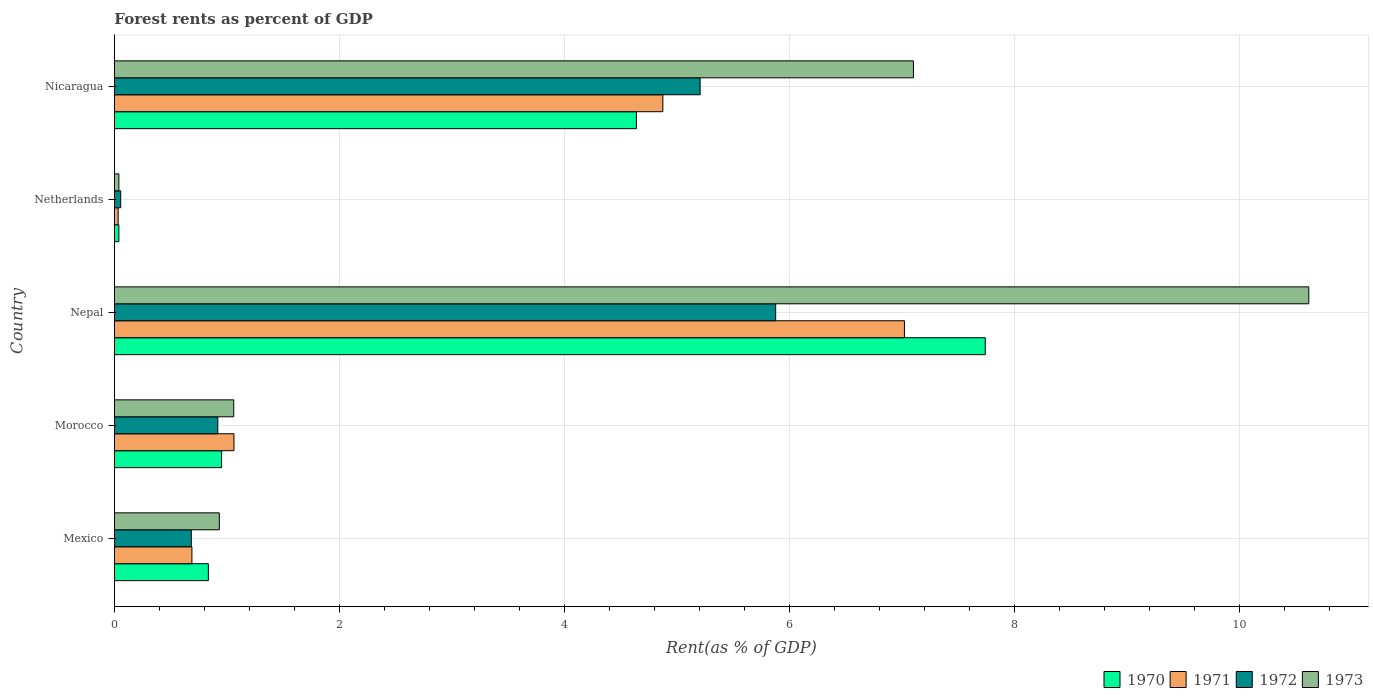How many different coloured bars are there?
Give a very brief answer. 4. Are the number of bars on each tick of the Y-axis equal?
Make the answer very short. Yes. How many bars are there on the 3rd tick from the bottom?
Give a very brief answer. 4. What is the label of the 2nd group of bars from the top?
Ensure brevity in your answer.  Netherlands. What is the forest rent in 1973 in Netherlands?
Ensure brevity in your answer.  0.04. Across all countries, what is the maximum forest rent in 1970?
Offer a very short reply. 7.74. Across all countries, what is the minimum forest rent in 1973?
Your answer should be compact. 0.04. In which country was the forest rent in 1972 maximum?
Make the answer very short. Nepal. In which country was the forest rent in 1970 minimum?
Your response must be concise. Netherlands. What is the total forest rent in 1973 in the graph?
Offer a terse response. 19.75. What is the difference between the forest rent in 1973 in Morocco and that in Netherlands?
Your response must be concise. 1.02. What is the difference between the forest rent in 1973 in Morocco and the forest rent in 1972 in Nicaragua?
Make the answer very short. -4.14. What is the average forest rent in 1970 per country?
Offer a very short reply. 2.84. What is the difference between the forest rent in 1970 and forest rent in 1972 in Mexico?
Provide a succinct answer. 0.15. What is the ratio of the forest rent in 1972 in Mexico to that in Nepal?
Keep it short and to the point. 0.12. Is the forest rent in 1972 in Morocco less than that in Netherlands?
Your response must be concise. No. Is the difference between the forest rent in 1970 in Morocco and Netherlands greater than the difference between the forest rent in 1972 in Morocco and Netherlands?
Offer a very short reply. Yes. What is the difference between the highest and the second highest forest rent in 1972?
Offer a very short reply. 0.67. What is the difference between the highest and the lowest forest rent in 1971?
Your answer should be very brief. 6.99. What does the 4th bar from the top in Mexico represents?
Offer a terse response. 1970. Is it the case that in every country, the sum of the forest rent in 1973 and forest rent in 1972 is greater than the forest rent in 1971?
Offer a very short reply. Yes. How many bars are there?
Offer a very short reply. 20. Are all the bars in the graph horizontal?
Ensure brevity in your answer.  Yes. How many countries are there in the graph?
Provide a succinct answer. 5. Are the values on the major ticks of X-axis written in scientific E-notation?
Your answer should be very brief. No. Does the graph contain any zero values?
Offer a terse response. No. How many legend labels are there?
Give a very brief answer. 4. What is the title of the graph?
Your answer should be very brief. Forest rents as percent of GDP. Does "1960" appear as one of the legend labels in the graph?
Make the answer very short. No. What is the label or title of the X-axis?
Offer a very short reply. Rent(as % of GDP). What is the Rent(as % of GDP) of 1970 in Mexico?
Give a very brief answer. 0.83. What is the Rent(as % of GDP) in 1971 in Mexico?
Make the answer very short. 0.69. What is the Rent(as % of GDP) in 1972 in Mexico?
Provide a short and direct response. 0.68. What is the Rent(as % of GDP) of 1973 in Mexico?
Keep it short and to the point. 0.93. What is the Rent(as % of GDP) of 1970 in Morocco?
Make the answer very short. 0.95. What is the Rent(as % of GDP) in 1971 in Morocco?
Your response must be concise. 1.06. What is the Rent(as % of GDP) in 1972 in Morocco?
Provide a short and direct response. 0.92. What is the Rent(as % of GDP) in 1973 in Morocco?
Keep it short and to the point. 1.06. What is the Rent(as % of GDP) in 1970 in Nepal?
Provide a short and direct response. 7.74. What is the Rent(as % of GDP) in 1971 in Nepal?
Ensure brevity in your answer.  7.02. What is the Rent(as % of GDP) in 1972 in Nepal?
Keep it short and to the point. 5.88. What is the Rent(as % of GDP) in 1973 in Nepal?
Your answer should be compact. 10.61. What is the Rent(as % of GDP) of 1970 in Netherlands?
Your answer should be very brief. 0.04. What is the Rent(as % of GDP) in 1971 in Netherlands?
Provide a succinct answer. 0.03. What is the Rent(as % of GDP) of 1972 in Netherlands?
Offer a terse response. 0.06. What is the Rent(as % of GDP) in 1973 in Netherlands?
Ensure brevity in your answer.  0.04. What is the Rent(as % of GDP) of 1970 in Nicaragua?
Provide a succinct answer. 4.64. What is the Rent(as % of GDP) of 1971 in Nicaragua?
Make the answer very short. 4.87. What is the Rent(as % of GDP) of 1972 in Nicaragua?
Your answer should be very brief. 5.21. What is the Rent(as % of GDP) of 1973 in Nicaragua?
Give a very brief answer. 7.1. Across all countries, what is the maximum Rent(as % of GDP) of 1970?
Your response must be concise. 7.74. Across all countries, what is the maximum Rent(as % of GDP) of 1971?
Keep it short and to the point. 7.02. Across all countries, what is the maximum Rent(as % of GDP) of 1972?
Keep it short and to the point. 5.88. Across all countries, what is the maximum Rent(as % of GDP) in 1973?
Keep it short and to the point. 10.61. Across all countries, what is the minimum Rent(as % of GDP) of 1970?
Provide a succinct answer. 0.04. Across all countries, what is the minimum Rent(as % of GDP) of 1971?
Keep it short and to the point. 0.03. Across all countries, what is the minimum Rent(as % of GDP) of 1972?
Offer a very short reply. 0.06. Across all countries, what is the minimum Rent(as % of GDP) in 1973?
Your response must be concise. 0.04. What is the total Rent(as % of GDP) of 1970 in the graph?
Ensure brevity in your answer.  14.2. What is the total Rent(as % of GDP) in 1971 in the graph?
Ensure brevity in your answer.  13.68. What is the total Rent(as % of GDP) in 1972 in the graph?
Offer a very short reply. 12.74. What is the total Rent(as % of GDP) of 1973 in the graph?
Keep it short and to the point. 19.75. What is the difference between the Rent(as % of GDP) of 1970 in Mexico and that in Morocco?
Ensure brevity in your answer.  -0.12. What is the difference between the Rent(as % of GDP) in 1971 in Mexico and that in Morocco?
Provide a succinct answer. -0.37. What is the difference between the Rent(as % of GDP) in 1972 in Mexico and that in Morocco?
Keep it short and to the point. -0.24. What is the difference between the Rent(as % of GDP) of 1973 in Mexico and that in Morocco?
Your answer should be very brief. -0.13. What is the difference between the Rent(as % of GDP) in 1970 in Mexico and that in Nepal?
Give a very brief answer. -6.9. What is the difference between the Rent(as % of GDP) of 1971 in Mexico and that in Nepal?
Your answer should be compact. -6.33. What is the difference between the Rent(as % of GDP) of 1972 in Mexico and that in Nepal?
Keep it short and to the point. -5.19. What is the difference between the Rent(as % of GDP) in 1973 in Mexico and that in Nepal?
Provide a succinct answer. -9.68. What is the difference between the Rent(as % of GDP) of 1970 in Mexico and that in Netherlands?
Your answer should be very brief. 0.8. What is the difference between the Rent(as % of GDP) of 1971 in Mexico and that in Netherlands?
Your answer should be compact. 0.66. What is the difference between the Rent(as % of GDP) in 1972 in Mexico and that in Netherlands?
Make the answer very short. 0.63. What is the difference between the Rent(as % of GDP) in 1973 in Mexico and that in Netherlands?
Give a very brief answer. 0.89. What is the difference between the Rent(as % of GDP) of 1970 in Mexico and that in Nicaragua?
Provide a succinct answer. -3.8. What is the difference between the Rent(as % of GDP) in 1971 in Mexico and that in Nicaragua?
Keep it short and to the point. -4.19. What is the difference between the Rent(as % of GDP) in 1972 in Mexico and that in Nicaragua?
Offer a very short reply. -4.52. What is the difference between the Rent(as % of GDP) of 1973 in Mexico and that in Nicaragua?
Keep it short and to the point. -6.17. What is the difference between the Rent(as % of GDP) of 1970 in Morocco and that in Nepal?
Keep it short and to the point. -6.79. What is the difference between the Rent(as % of GDP) of 1971 in Morocco and that in Nepal?
Provide a short and direct response. -5.96. What is the difference between the Rent(as % of GDP) of 1972 in Morocco and that in Nepal?
Provide a succinct answer. -4.96. What is the difference between the Rent(as % of GDP) of 1973 in Morocco and that in Nepal?
Your answer should be compact. -9.55. What is the difference between the Rent(as % of GDP) in 1970 in Morocco and that in Netherlands?
Your answer should be very brief. 0.91. What is the difference between the Rent(as % of GDP) of 1971 in Morocco and that in Netherlands?
Make the answer very short. 1.03. What is the difference between the Rent(as % of GDP) in 1972 in Morocco and that in Netherlands?
Offer a very short reply. 0.86. What is the difference between the Rent(as % of GDP) in 1973 in Morocco and that in Netherlands?
Ensure brevity in your answer.  1.02. What is the difference between the Rent(as % of GDP) of 1970 in Morocco and that in Nicaragua?
Ensure brevity in your answer.  -3.69. What is the difference between the Rent(as % of GDP) in 1971 in Morocco and that in Nicaragua?
Ensure brevity in your answer.  -3.81. What is the difference between the Rent(as % of GDP) in 1972 in Morocco and that in Nicaragua?
Ensure brevity in your answer.  -4.29. What is the difference between the Rent(as % of GDP) in 1973 in Morocco and that in Nicaragua?
Your answer should be compact. -6.04. What is the difference between the Rent(as % of GDP) of 1970 in Nepal and that in Netherlands?
Ensure brevity in your answer.  7.7. What is the difference between the Rent(as % of GDP) in 1971 in Nepal and that in Netherlands?
Make the answer very short. 6.99. What is the difference between the Rent(as % of GDP) in 1972 in Nepal and that in Netherlands?
Provide a short and direct response. 5.82. What is the difference between the Rent(as % of GDP) in 1973 in Nepal and that in Netherlands?
Your answer should be very brief. 10.58. What is the difference between the Rent(as % of GDP) in 1970 in Nepal and that in Nicaragua?
Offer a very short reply. 3.1. What is the difference between the Rent(as % of GDP) of 1971 in Nepal and that in Nicaragua?
Provide a succinct answer. 2.15. What is the difference between the Rent(as % of GDP) of 1972 in Nepal and that in Nicaragua?
Provide a succinct answer. 0.67. What is the difference between the Rent(as % of GDP) of 1973 in Nepal and that in Nicaragua?
Provide a short and direct response. 3.51. What is the difference between the Rent(as % of GDP) of 1970 in Netherlands and that in Nicaragua?
Provide a short and direct response. -4.6. What is the difference between the Rent(as % of GDP) in 1971 in Netherlands and that in Nicaragua?
Give a very brief answer. -4.84. What is the difference between the Rent(as % of GDP) of 1972 in Netherlands and that in Nicaragua?
Give a very brief answer. -5.15. What is the difference between the Rent(as % of GDP) of 1973 in Netherlands and that in Nicaragua?
Offer a very short reply. -7.06. What is the difference between the Rent(as % of GDP) of 1970 in Mexico and the Rent(as % of GDP) of 1971 in Morocco?
Your response must be concise. -0.23. What is the difference between the Rent(as % of GDP) in 1970 in Mexico and the Rent(as % of GDP) in 1972 in Morocco?
Provide a succinct answer. -0.08. What is the difference between the Rent(as % of GDP) of 1970 in Mexico and the Rent(as % of GDP) of 1973 in Morocco?
Your answer should be very brief. -0.23. What is the difference between the Rent(as % of GDP) in 1971 in Mexico and the Rent(as % of GDP) in 1972 in Morocco?
Provide a short and direct response. -0.23. What is the difference between the Rent(as % of GDP) of 1971 in Mexico and the Rent(as % of GDP) of 1973 in Morocco?
Offer a terse response. -0.37. What is the difference between the Rent(as % of GDP) of 1972 in Mexico and the Rent(as % of GDP) of 1973 in Morocco?
Your answer should be compact. -0.38. What is the difference between the Rent(as % of GDP) of 1970 in Mexico and the Rent(as % of GDP) of 1971 in Nepal?
Make the answer very short. -6.19. What is the difference between the Rent(as % of GDP) in 1970 in Mexico and the Rent(as % of GDP) in 1972 in Nepal?
Ensure brevity in your answer.  -5.04. What is the difference between the Rent(as % of GDP) in 1970 in Mexico and the Rent(as % of GDP) in 1973 in Nepal?
Provide a succinct answer. -9.78. What is the difference between the Rent(as % of GDP) of 1971 in Mexico and the Rent(as % of GDP) of 1972 in Nepal?
Your answer should be compact. -5.19. What is the difference between the Rent(as % of GDP) of 1971 in Mexico and the Rent(as % of GDP) of 1973 in Nepal?
Your answer should be very brief. -9.93. What is the difference between the Rent(as % of GDP) of 1972 in Mexico and the Rent(as % of GDP) of 1973 in Nepal?
Your answer should be very brief. -9.93. What is the difference between the Rent(as % of GDP) of 1970 in Mexico and the Rent(as % of GDP) of 1971 in Netherlands?
Provide a short and direct response. 0.8. What is the difference between the Rent(as % of GDP) in 1970 in Mexico and the Rent(as % of GDP) in 1972 in Netherlands?
Provide a succinct answer. 0.78. What is the difference between the Rent(as % of GDP) in 1970 in Mexico and the Rent(as % of GDP) in 1973 in Netherlands?
Your answer should be very brief. 0.8. What is the difference between the Rent(as % of GDP) in 1971 in Mexico and the Rent(as % of GDP) in 1972 in Netherlands?
Offer a terse response. 0.63. What is the difference between the Rent(as % of GDP) in 1971 in Mexico and the Rent(as % of GDP) in 1973 in Netherlands?
Offer a very short reply. 0.65. What is the difference between the Rent(as % of GDP) in 1972 in Mexico and the Rent(as % of GDP) in 1973 in Netherlands?
Keep it short and to the point. 0.64. What is the difference between the Rent(as % of GDP) in 1970 in Mexico and the Rent(as % of GDP) in 1971 in Nicaragua?
Your answer should be very brief. -4.04. What is the difference between the Rent(as % of GDP) of 1970 in Mexico and the Rent(as % of GDP) of 1972 in Nicaragua?
Your answer should be compact. -4.37. What is the difference between the Rent(as % of GDP) in 1970 in Mexico and the Rent(as % of GDP) in 1973 in Nicaragua?
Your response must be concise. -6.27. What is the difference between the Rent(as % of GDP) of 1971 in Mexico and the Rent(as % of GDP) of 1972 in Nicaragua?
Keep it short and to the point. -4.52. What is the difference between the Rent(as % of GDP) of 1971 in Mexico and the Rent(as % of GDP) of 1973 in Nicaragua?
Offer a very short reply. -6.41. What is the difference between the Rent(as % of GDP) in 1972 in Mexico and the Rent(as % of GDP) in 1973 in Nicaragua?
Keep it short and to the point. -6.42. What is the difference between the Rent(as % of GDP) of 1970 in Morocco and the Rent(as % of GDP) of 1971 in Nepal?
Offer a terse response. -6.07. What is the difference between the Rent(as % of GDP) in 1970 in Morocco and the Rent(as % of GDP) in 1972 in Nepal?
Ensure brevity in your answer.  -4.92. What is the difference between the Rent(as % of GDP) in 1970 in Morocco and the Rent(as % of GDP) in 1973 in Nepal?
Offer a terse response. -9.66. What is the difference between the Rent(as % of GDP) in 1971 in Morocco and the Rent(as % of GDP) in 1972 in Nepal?
Make the answer very short. -4.81. What is the difference between the Rent(as % of GDP) of 1971 in Morocco and the Rent(as % of GDP) of 1973 in Nepal?
Give a very brief answer. -9.55. What is the difference between the Rent(as % of GDP) in 1972 in Morocco and the Rent(as % of GDP) in 1973 in Nepal?
Your response must be concise. -9.7. What is the difference between the Rent(as % of GDP) in 1970 in Morocco and the Rent(as % of GDP) in 1971 in Netherlands?
Make the answer very short. 0.92. What is the difference between the Rent(as % of GDP) in 1970 in Morocco and the Rent(as % of GDP) in 1972 in Netherlands?
Offer a terse response. 0.9. What is the difference between the Rent(as % of GDP) in 1970 in Morocco and the Rent(as % of GDP) in 1973 in Netherlands?
Your response must be concise. 0.91. What is the difference between the Rent(as % of GDP) in 1971 in Morocco and the Rent(as % of GDP) in 1972 in Netherlands?
Provide a short and direct response. 1.01. What is the difference between the Rent(as % of GDP) of 1971 in Morocco and the Rent(as % of GDP) of 1973 in Netherlands?
Provide a short and direct response. 1.02. What is the difference between the Rent(as % of GDP) of 1972 in Morocco and the Rent(as % of GDP) of 1973 in Netherlands?
Your answer should be very brief. 0.88. What is the difference between the Rent(as % of GDP) in 1970 in Morocco and the Rent(as % of GDP) in 1971 in Nicaragua?
Offer a very short reply. -3.92. What is the difference between the Rent(as % of GDP) of 1970 in Morocco and the Rent(as % of GDP) of 1972 in Nicaragua?
Your response must be concise. -4.25. What is the difference between the Rent(as % of GDP) of 1970 in Morocco and the Rent(as % of GDP) of 1973 in Nicaragua?
Provide a succinct answer. -6.15. What is the difference between the Rent(as % of GDP) of 1971 in Morocco and the Rent(as % of GDP) of 1972 in Nicaragua?
Keep it short and to the point. -4.14. What is the difference between the Rent(as % of GDP) of 1971 in Morocco and the Rent(as % of GDP) of 1973 in Nicaragua?
Keep it short and to the point. -6.04. What is the difference between the Rent(as % of GDP) in 1972 in Morocco and the Rent(as % of GDP) in 1973 in Nicaragua?
Your response must be concise. -6.18. What is the difference between the Rent(as % of GDP) in 1970 in Nepal and the Rent(as % of GDP) in 1971 in Netherlands?
Provide a short and direct response. 7.71. What is the difference between the Rent(as % of GDP) of 1970 in Nepal and the Rent(as % of GDP) of 1972 in Netherlands?
Keep it short and to the point. 7.68. What is the difference between the Rent(as % of GDP) of 1971 in Nepal and the Rent(as % of GDP) of 1972 in Netherlands?
Offer a terse response. 6.97. What is the difference between the Rent(as % of GDP) of 1971 in Nepal and the Rent(as % of GDP) of 1973 in Netherlands?
Offer a terse response. 6.98. What is the difference between the Rent(as % of GDP) in 1972 in Nepal and the Rent(as % of GDP) in 1973 in Netherlands?
Your answer should be compact. 5.84. What is the difference between the Rent(as % of GDP) of 1970 in Nepal and the Rent(as % of GDP) of 1971 in Nicaragua?
Make the answer very short. 2.87. What is the difference between the Rent(as % of GDP) of 1970 in Nepal and the Rent(as % of GDP) of 1972 in Nicaragua?
Keep it short and to the point. 2.53. What is the difference between the Rent(as % of GDP) of 1970 in Nepal and the Rent(as % of GDP) of 1973 in Nicaragua?
Offer a very short reply. 0.64. What is the difference between the Rent(as % of GDP) of 1971 in Nepal and the Rent(as % of GDP) of 1972 in Nicaragua?
Provide a succinct answer. 1.82. What is the difference between the Rent(as % of GDP) in 1971 in Nepal and the Rent(as % of GDP) in 1973 in Nicaragua?
Keep it short and to the point. -0.08. What is the difference between the Rent(as % of GDP) of 1972 in Nepal and the Rent(as % of GDP) of 1973 in Nicaragua?
Your response must be concise. -1.22. What is the difference between the Rent(as % of GDP) in 1970 in Netherlands and the Rent(as % of GDP) in 1971 in Nicaragua?
Keep it short and to the point. -4.83. What is the difference between the Rent(as % of GDP) of 1970 in Netherlands and the Rent(as % of GDP) of 1972 in Nicaragua?
Make the answer very short. -5.17. What is the difference between the Rent(as % of GDP) in 1970 in Netherlands and the Rent(as % of GDP) in 1973 in Nicaragua?
Offer a terse response. -7.06. What is the difference between the Rent(as % of GDP) of 1971 in Netherlands and the Rent(as % of GDP) of 1972 in Nicaragua?
Your answer should be very brief. -5.17. What is the difference between the Rent(as % of GDP) in 1971 in Netherlands and the Rent(as % of GDP) in 1973 in Nicaragua?
Provide a succinct answer. -7.07. What is the difference between the Rent(as % of GDP) of 1972 in Netherlands and the Rent(as % of GDP) of 1973 in Nicaragua?
Your answer should be very brief. -7.05. What is the average Rent(as % of GDP) of 1970 per country?
Provide a succinct answer. 2.84. What is the average Rent(as % of GDP) of 1971 per country?
Make the answer very short. 2.74. What is the average Rent(as % of GDP) in 1972 per country?
Give a very brief answer. 2.55. What is the average Rent(as % of GDP) in 1973 per country?
Provide a short and direct response. 3.95. What is the difference between the Rent(as % of GDP) in 1970 and Rent(as % of GDP) in 1971 in Mexico?
Give a very brief answer. 0.15. What is the difference between the Rent(as % of GDP) in 1970 and Rent(as % of GDP) in 1972 in Mexico?
Give a very brief answer. 0.15. What is the difference between the Rent(as % of GDP) in 1970 and Rent(as % of GDP) in 1973 in Mexico?
Offer a terse response. -0.1. What is the difference between the Rent(as % of GDP) of 1971 and Rent(as % of GDP) of 1972 in Mexico?
Provide a short and direct response. 0.01. What is the difference between the Rent(as % of GDP) of 1971 and Rent(as % of GDP) of 1973 in Mexico?
Offer a very short reply. -0.24. What is the difference between the Rent(as % of GDP) of 1972 and Rent(as % of GDP) of 1973 in Mexico?
Give a very brief answer. -0.25. What is the difference between the Rent(as % of GDP) in 1970 and Rent(as % of GDP) in 1971 in Morocco?
Your response must be concise. -0.11. What is the difference between the Rent(as % of GDP) in 1970 and Rent(as % of GDP) in 1972 in Morocco?
Your answer should be very brief. 0.03. What is the difference between the Rent(as % of GDP) of 1970 and Rent(as % of GDP) of 1973 in Morocco?
Your answer should be compact. -0.11. What is the difference between the Rent(as % of GDP) of 1971 and Rent(as % of GDP) of 1972 in Morocco?
Give a very brief answer. 0.14. What is the difference between the Rent(as % of GDP) in 1971 and Rent(as % of GDP) in 1973 in Morocco?
Your response must be concise. 0. What is the difference between the Rent(as % of GDP) of 1972 and Rent(as % of GDP) of 1973 in Morocco?
Give a very brief answer. -0.14. What is the difference between the Rent(as % of GDP) of 1970 and Rent(as % of GDP) of 1971 in Nepal?
Keep it short and to the point. 0.72. What is the difference between the Rent(as % of GDP) of 1970 and Rent(as % of GDP) of 1972 in Nepal?
Offer a very short reply. 1.86. What is the difference between the Rent(as % of GDP) of 1970 and Rent(as % of GDP) of 1973 in Nepal?
Make the answer very short. -2.88. What is the difference between the Rent(as % of GDP) in 1971 and Rent(as % of GDP) in 1972 in Nepal?
Your answer should be very brief. 1.14. What is the difference between the Rent(as % of GDP) of 1971 and Rent(as % of GDP) of 1973 in Nepal?
Your response must be concise. -3.59. What is the difference between the Rent(as % of GDP) in 1972 and Rent(as % of GDP) in 1973 in Nepal?
Give a very brief answer. -4.74. What is the difference between the Rent(as % of GDP) of 1970 and Rent(as % of GDP) of 1971 in Netherlands?
Offer a very short reply. 0.01. What is the difference between the Rent(as % of GDP) in 1970 and Rent(as % of GDP) in 1972 in Netherlands?
Offer a terse response. -0.02. What is the difference between the Rent(as % of GDP) of 1970 and Rent(as % of GDP) of 1973 in Netherlands?
Provide a short and direct response. -0. What is the difference between the Rent(as % of GDP) of 1971 and Rent(as % of GDP) of 1972 in Netherlands?
Keep it short and to the point. -0.02. What is the difference between the Rent(as % of GDP) in 1971 and Rent(as % of GDP) in 1973 in Netherlands?
Your response must be concise. -0.01. What is the difference between the Rent(as % of GDP) of 1972 and Rent(as % of GDP) of 1973 in Netherlands?
Make the answer very short. 0.02. What is the difference between the Rent(as % of GDP) in 1970 and Rent(as % of GDP) in 1971 in Nicaragua?
Provide a succinct answer. -0.23. What is the difference between the Rent(as % of GDP) of 1970 and Rent(as % of GDP) of 1972 in Nicaragua?
Your response must be concise. -0.57. What is the difference between the Rent(as % of GDP) in 1970 and Rent(as % of GDP) in 1973 in Nicaragua?
Provide a succinct answer. -2.46. What is the difference between the Rent(as % of GDP) of 1971 and Rent(as % of GDP) of 1972 in Nicaragua?
Give a very brief answer. -0.33. What is the difference between the Rent(as % of GDP) of 1971 and Rent(as % of GDP) of 1973 in Nicaragua?
Make the answer very short. -2.23. What is the difference between the Rent(as % of GDP) of 1972 and Rent(as % of GDP) of 1973 in Nicaragua?
Offer a very short reply. -1.9. What is the ratio of the Rent(as % of GDP) of 1970 in Mexico to that in Morocco?
Make the answer very short. 0.88. What is the ratio of the Rent(as % of GDP) of 1971 in Mexico to that in Morocco?
Your answer should be compact. 0.65. What is the ratio of the Rent(as % of GDP) of 1972 in Mexico to that in Morocco?
Ensure brevity in your answer.  0.74. What is the ratio of the Rent(as % of GDP) in 1973 in Mexico to that in Morocco?
Give a very brief answer. 0.88. What is the ratio of the Rent(as % of GDP) of 1970 in Mexico to that in Nepal?
Keep it short and to the point. 0.11. What is the ratio of the Rent(as % of GDP) of 1971 in Mexico to that in Nepal?
Your answer should be very brief. 0.1. What is the ratio of the Rent(as % of GDP) of 1972 in Mexico to that in Nepal?
Your answer should be very brief. 0.12. What is the ratio of the Rent(as % of GDP) in 1973 in Mexico to that in Nepal?
Keep it short and to the point. 0.09. What is the ratio of the Rent(as % of GDP) in 1970 in Mexico to that in Netherlands?
Your response must be concise. 21.24. What is the ratio of the Rent(as % of GDP) in 1971 in Mexico to that in Netherlands?
Offer a very short reply. 20.75. What is the ratio of the Rent(as % of GDP) of 1972 in Mexico to that in Netherlands?
Ensure brevity in your answer.  12.33. What is the ratio of the Rent(as % of GDP) in 1973 in Mexico to that in Netherlands?
Give a very brief answer. 23.61. What is the ratio of the Rent(as % of GDP) of 1970 in Mexico to that in Nicaragua?
Offer a very short reply. 0.18. What is the ratio of the Rent(as % of GDP) of 1971 in Mexico to that in Nicaragua?
Keep it short and to the point. 0.14. What is the ratio of the Rent(as % of GDP) of 1972 in Mexico to that in Nicaragua?
Provide a short and direct response. 0.13. What is the ratio of the Rent(as % of GDP) in 1973 in Mexico to that in Nicaragua?
Your answer should be very brief. 0.13. What is the ratio of the Rent(as % of GDP) in 1970 in Morocco to that in Nepal?
Provide a short and direct response. 0.12. What is the ratio of the Rent(as % of GDP) of 1971 in Morocco to that in Nepal?
Offer a very short reply. 0.15. What is the ratio of the Rent(as % of GDP) in 1972 in Morocco to that in Nepal?
Provide a short and direct response. 0.16. What is the ratio of the Rent(as % of GDP) of 1973 in Morocco to that in Nepal?
Offer a very short reply. 0.1. What is the ratio of the Rent(as % of GDP) of 1970 in Morocco to that in Netherlands?
Keep it short and to the point. 24.22. What is the ratio of the Rent(as % of GDP) in 1971 in Morocco to that in Netherlands?
Provide a succinct answer. 32.01. What is the ratio of the Rent(as % of GDP) of 1972 in Morocco to that in Netherlands?
Offer a terse response. 16.58. What is the ratio of the Rent(as % of GDP) of 1973 in Morocco to that in Netherlands?
Your response must be concise. 26.86. What is the ratio of the Rent(as % of GDP) of 1970 in Morocco to that in Nicaragua?
Offer a very short reply. 0.21. What is the ratio of the Rent(as % of GDP) in 1971 in Morocco to that in Nicaragua?
Offer a very short reply. 0.22. What is the ratio of the Rent(as % of GDP) in 1972 in Morocco to that in Nicaragua?
Make the answer very short. 0.18. What is the ratio of the Rent(as % of GDP) in 1973 in Morocco to that in Nicaragua?
Offer a very short reply. 0.15. What is the ratio of the Rent(as % of GDP) of 1970 in Nepal to that in Netherlands?
Your response must be concise. 196.89. What is the ratio of the Rent(as % of GDP) in 1971 in Nepal to that in Netherlands?
Offer a terse response. 211.52. What is the ratio of the Rent(as % of GDP) of 1972 in Nepal to that in Netherlands?
Offer a very short reply. 106.01. What is the ratio of the Rent(as % of GDP) in 1973 in Nepal to that in Netherlands?
Keep it short and to the point. 268.86. What is the ratio of the Rent(as % of GDP) in 1970 in Nepal to that in Nicaragua?
Keep it short and to the point. 1.67. What is the ratio of the Rent(as % of GDP) of 1971 in Nepal to that in Nicaragua?
Keep it short and to the point. 1.44. What is the ratio of the Rent(as % of GDP) of 1972 in Nepal to that in Nicaragua?
Your answer should be compact. 1.13. What is the ratio of the Rent(as % of GDP) of 1973 in Nepal to that in Nicaragua?
Offer a very short reply. 1.49. What is the ratio of the Rent(as % of GDP) of 1970 in Netherlands to that in Nicaragua?
Offer a very short reply. 0.01. What is the ratio of the Rent(as % of GDP) in 1971 in Netherlands to that in Nicaragua?
Ensure brevity in your answer.  0.01. What is the ratio of the Rent(as % of GDP) of 1972 in Netherlands to that in Nicaragua?
Provide a succinct answer. 0.01. What is the ratio of the Rent(as % of GDP) in 1973 in Netherlands to that in Nicaragua?
Provide a short and direct response. 0.01. What is the difference between the highest and the second highest Rent(as % of GDP) of 1970?
Make the answer very short. 3.1. What is the difference between the highest and the second highest Rent(as % of GDP) in 1971?
Provide a succinct answer. 2.15. What is the difference between the highest and the second highest Rent(as % of GDP) in 1972?
Make the answer very short. 0.67. What is the difference between the highest and the second highest Rent(as % of GDP) of 1973?
Your response must be concise. 3.51. What is the difference between the highest and the lowest Rent(as % of GDP) of 1970?
Your answer should be very brief. 7.7. What is the difference between the highest and the lowest Rent(as % of GDP) in 1971?
Keep it short and to the point. 6.99. What is the difference between the highest and the lowest Rent(as % of GDP) in 1972?
Keep it short and to the point. 5.82. What is the difference between the highest and the lowest Rent(as % of GDP) in 1973?
Keep it short and to the point. 10.58. 